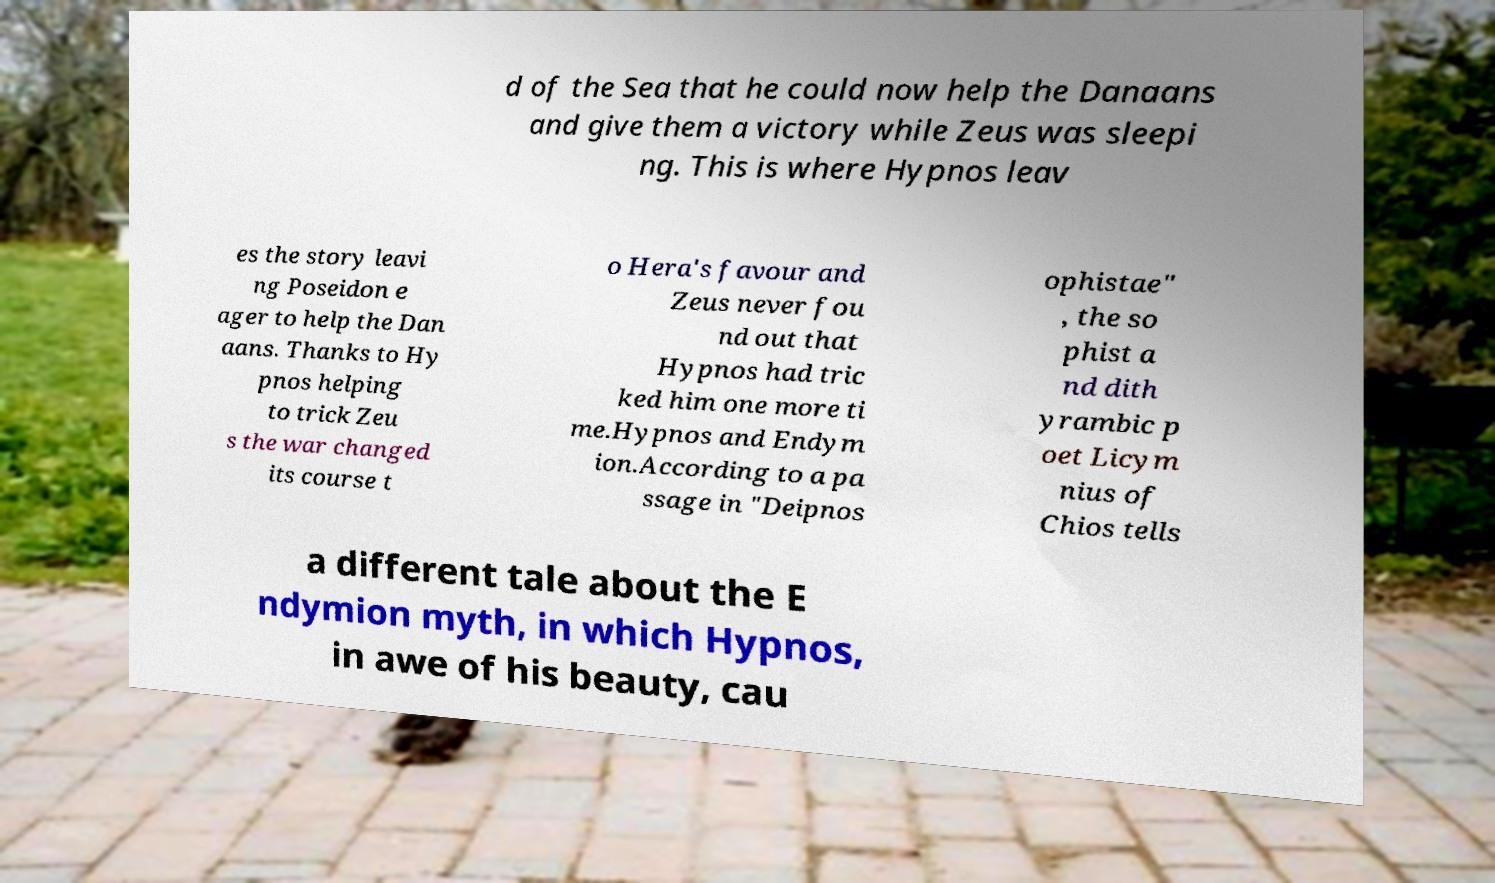Could you assist in decoding the text presented in this image and type it out clearly? d of the Sea that he could now help the Danaans and give them a victory while Zeus was sleepi ng. This is where Hypnos leav es the story leavi ng Poseidon e ager to help the Dan aans. Thanks to Hy pnos helping to trick Zeu s the war changed its course t o Hera's favour and Zeus never fou nd out that Hypnos had tric ked him one more ti me.Hypnos and Endym ion.According to a pa ssage in "Deipnos ophistae" , the so phist a nd dith yrambic p oet Licym nius of Chios tells a different tale about the E ndymion myth, in which Hypnos, in awe of his beauty, cau 